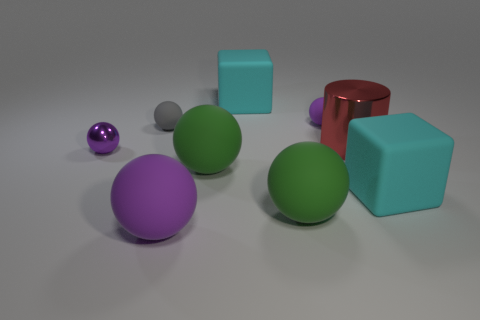There is a purple sphere that is made of the same material as the red object; what size is it?
Ensure brevity in your answer.  Small. The purple metallic thing has what size?
Offer a very short reply. Small. Is the material of the gray object the same as the red thing?
Give a very brief answer. No. How many spheres are either gray objects or large green objects?
Offer a terse response. 3. The metallic thing on the left side of the tiny rubber thing that is behind the tiny gray matte object is what color?
Offer a terse response. Purple. There is a big purple rubber thing in front of the ball that is behind the gray rubber sphere; what number of purple metal things are behind it?
Your answer should be very brief. 1. Is the shape of the small gray rubber thing that is left of the tiny purple rubber thing the same as the cyan thing that is behind the tiny purple metal thing?
Your response must be concise. No. How many objects are either big cyan matte objects or green matte objects?
Your response must be concise. 4. There is a cyan object to the right of the cube that is behind the metal cylinder; what is its material?
Offer a terse response. Rubber. Is there a metallic cylinder of the same color as the big shiny object?
Offer a very short reply. No. 